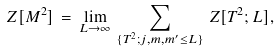<formula> <loc_0><loc_0><loc_500><loc_500>Z [ M ^ { 2 } ] \, = \, \lim _ { L \rightarrow \infty } \, \sum _ { \{ T ^ { 2 } ; j , m , m ^ { \prime } \leq L \} } \, Z [ T ^ { 2 } ; L ] ,</formula> 